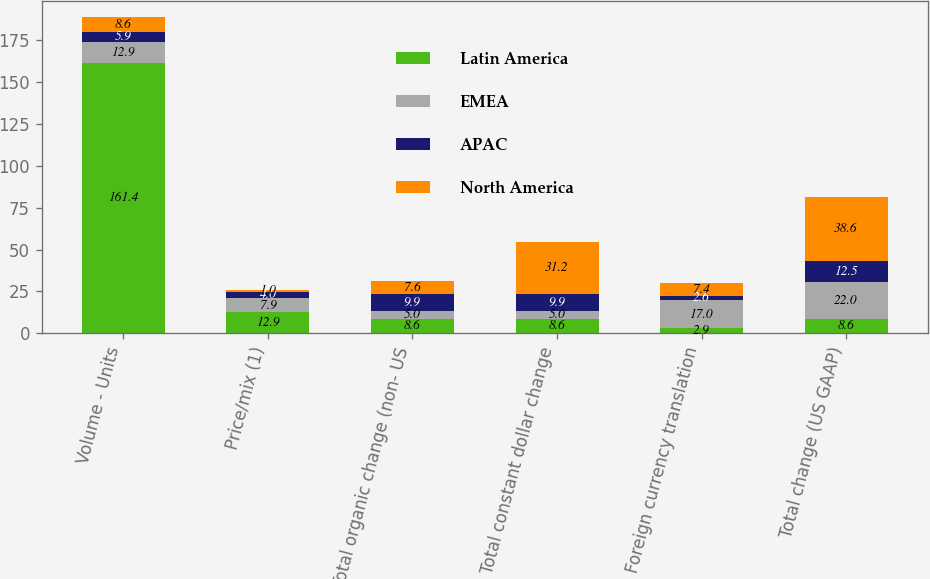<chart> <loc_0><loc_0><loc_500><loc_500><stacked_bar_chart><ecel><fcel>Volume - Units<fcel>Price/mix (1)<fcel>Total organic change (non- US<fcel>Total constant dollar change<fcel>Foreign currency translation<fcel>Total change (US GAAP)<nl><fcel>Latin America<fcel>161.4<fcel>12.9<fcel>8.6<fcel>8.6<fcel>2.9<fcel>8.6<nl><fcel>EMEA<fcel>12.9<fcel>7.9<fcel>5<fcel>5<fcel>17<fcel>22<nl><fcel>APAC<fcel>5.9<fcel>4<fcel>9.9<fcel>9.9<fcel>2.6<fcel>12.5<nl><fcel>North America<fcel>8.6<fcel>1<fcel>7.6<fcel>31.2<fcel>7.4<fcel>38.6<nl></chart> 